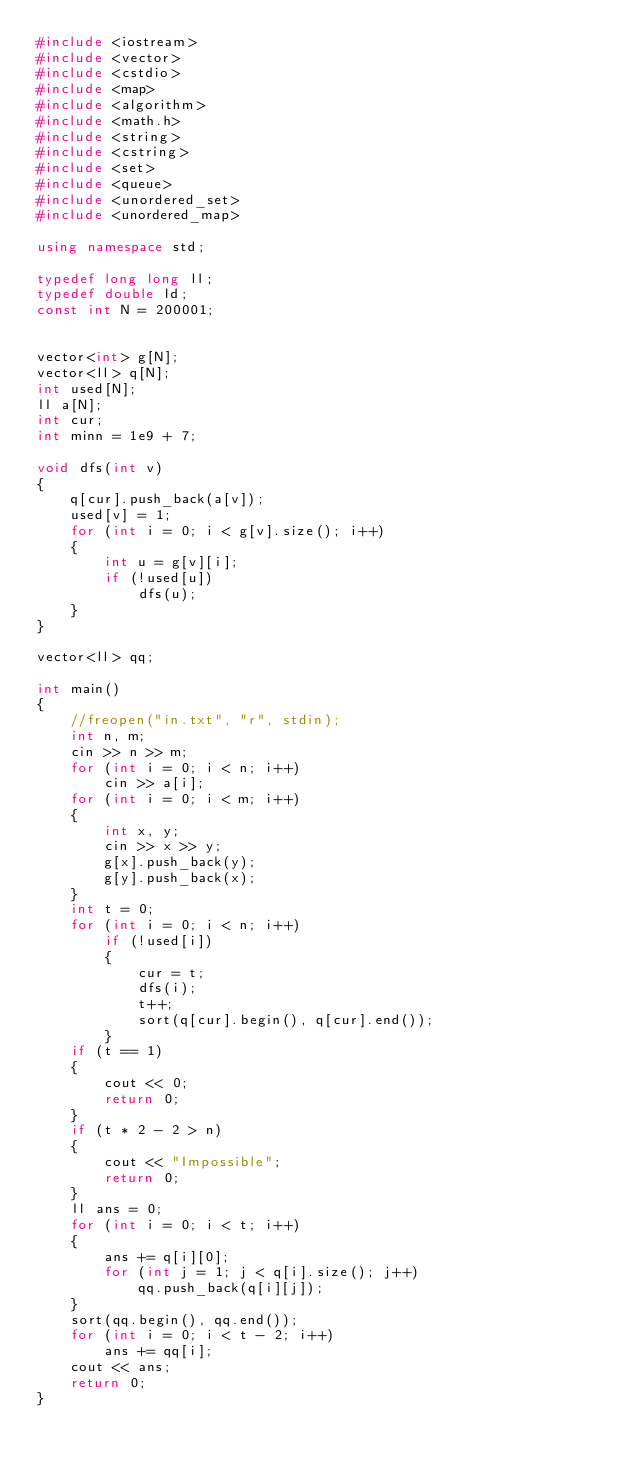Convert code to text. <code><loc_0><loc_0><loc_500><loc_500><_C++_>#include <iostream>
#include <vector>
#include <cstdio>
#include <map>
#include <algorithm>
#include <math.h>
#include <string>
#include <cstring>
#include <set>
#include <queue>
#include <unordered_set>
#include <unordered_map>

using namespace std;

typedef long long ll;
typedef double ld;
const int N = 200001;


vector<int> g[N];
vector<ll> q[N];
int used[N];
ll a[N];
int cur;
int minn = 1e9 + 7;

void dfs(int v)
{
    q[cur].push_back(a[v]);
    used[v] = 1;
    for (int i = 0; i < g[v].size(); i++)
    {
        int u = g[v][i];
        if (!used[u])
            dfs(u);
    }
}

vector<ll> qq;

int main()
{
    //freopen("in.txt", "r", stdin);
    int n, m;
    cin >> n >> m;
    for (int i = 0; i < n; i++)
        cin >> a[i];
    for (int i = 0; i < m; i++)
    {
        int x, y;
        cin >> x >> y;
        g[x].push_back(y);
        g[y].push_back(x);
    }
    int t = 0;
    for (int i = 0; i < n; i++)
        if (!used[i])
        {
            cur = t;
            dfs(i);
            t++;
            sort(q[cur].begin(), q[cur].end());
        }
    if (t == 1)
    {
        cout << 0;
        return 0;
    }
    if (t * 2 - 2 > n)
    {
        cout << "Impossible";
        return 0;
    }
    ll ans = 0;
    for (int i = 0; i < t; i++)
    {
        ans += q[i][0];
        for (int j = 1; j < q[i].size(); j++)
            qq.push_back(q[i][j]);
    }
    sort(qq.begin(), qq.end());
    for (int i = 0; i < t - 2; i++)
        ans += qq[i];
    cout << ans;
    return 0;
}
</code> 